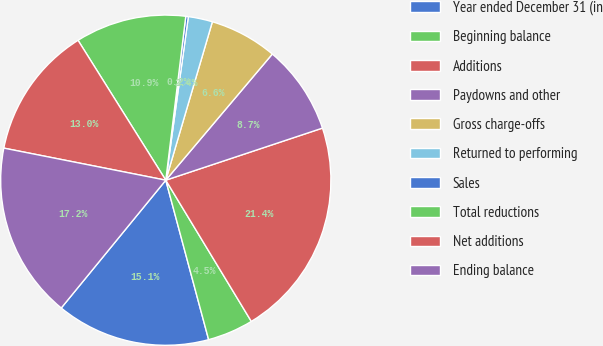Convert chart to OTSL. <chart><loc_0><loc_0><loc_500><loc_500><pie_chart><fcel>Year ended December 31 (in<fcel>Beginning balance<fcel>Additions<fcel>Paydowns and other<fcel>Gross charge-offs<fcel>Returned to performing<fcel>Sales<fcel>Total reductions<fcel>Net additions<fcel>Ending balance<nl><fcel>15.09%<fcel>4.49%<fcel>21.44%<fcel>8.73%<fcel>6.61%<fcel>2.37%<fcel>0.25%<fcel>10.85%<fcel>12.97%<fcel>17.2%<nl></chart> 